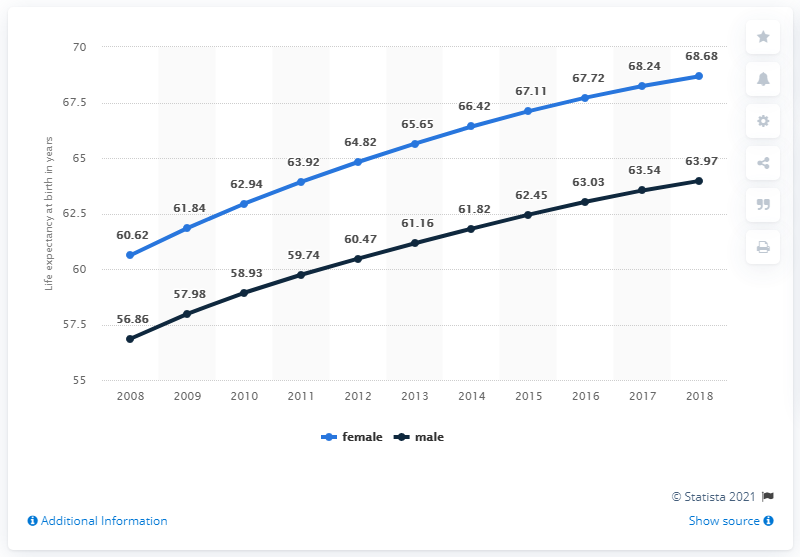Highlight a few significant elements in this photo. The sum of the highest life expectancy is 132.65 years. Life expectancy does not decrease. 